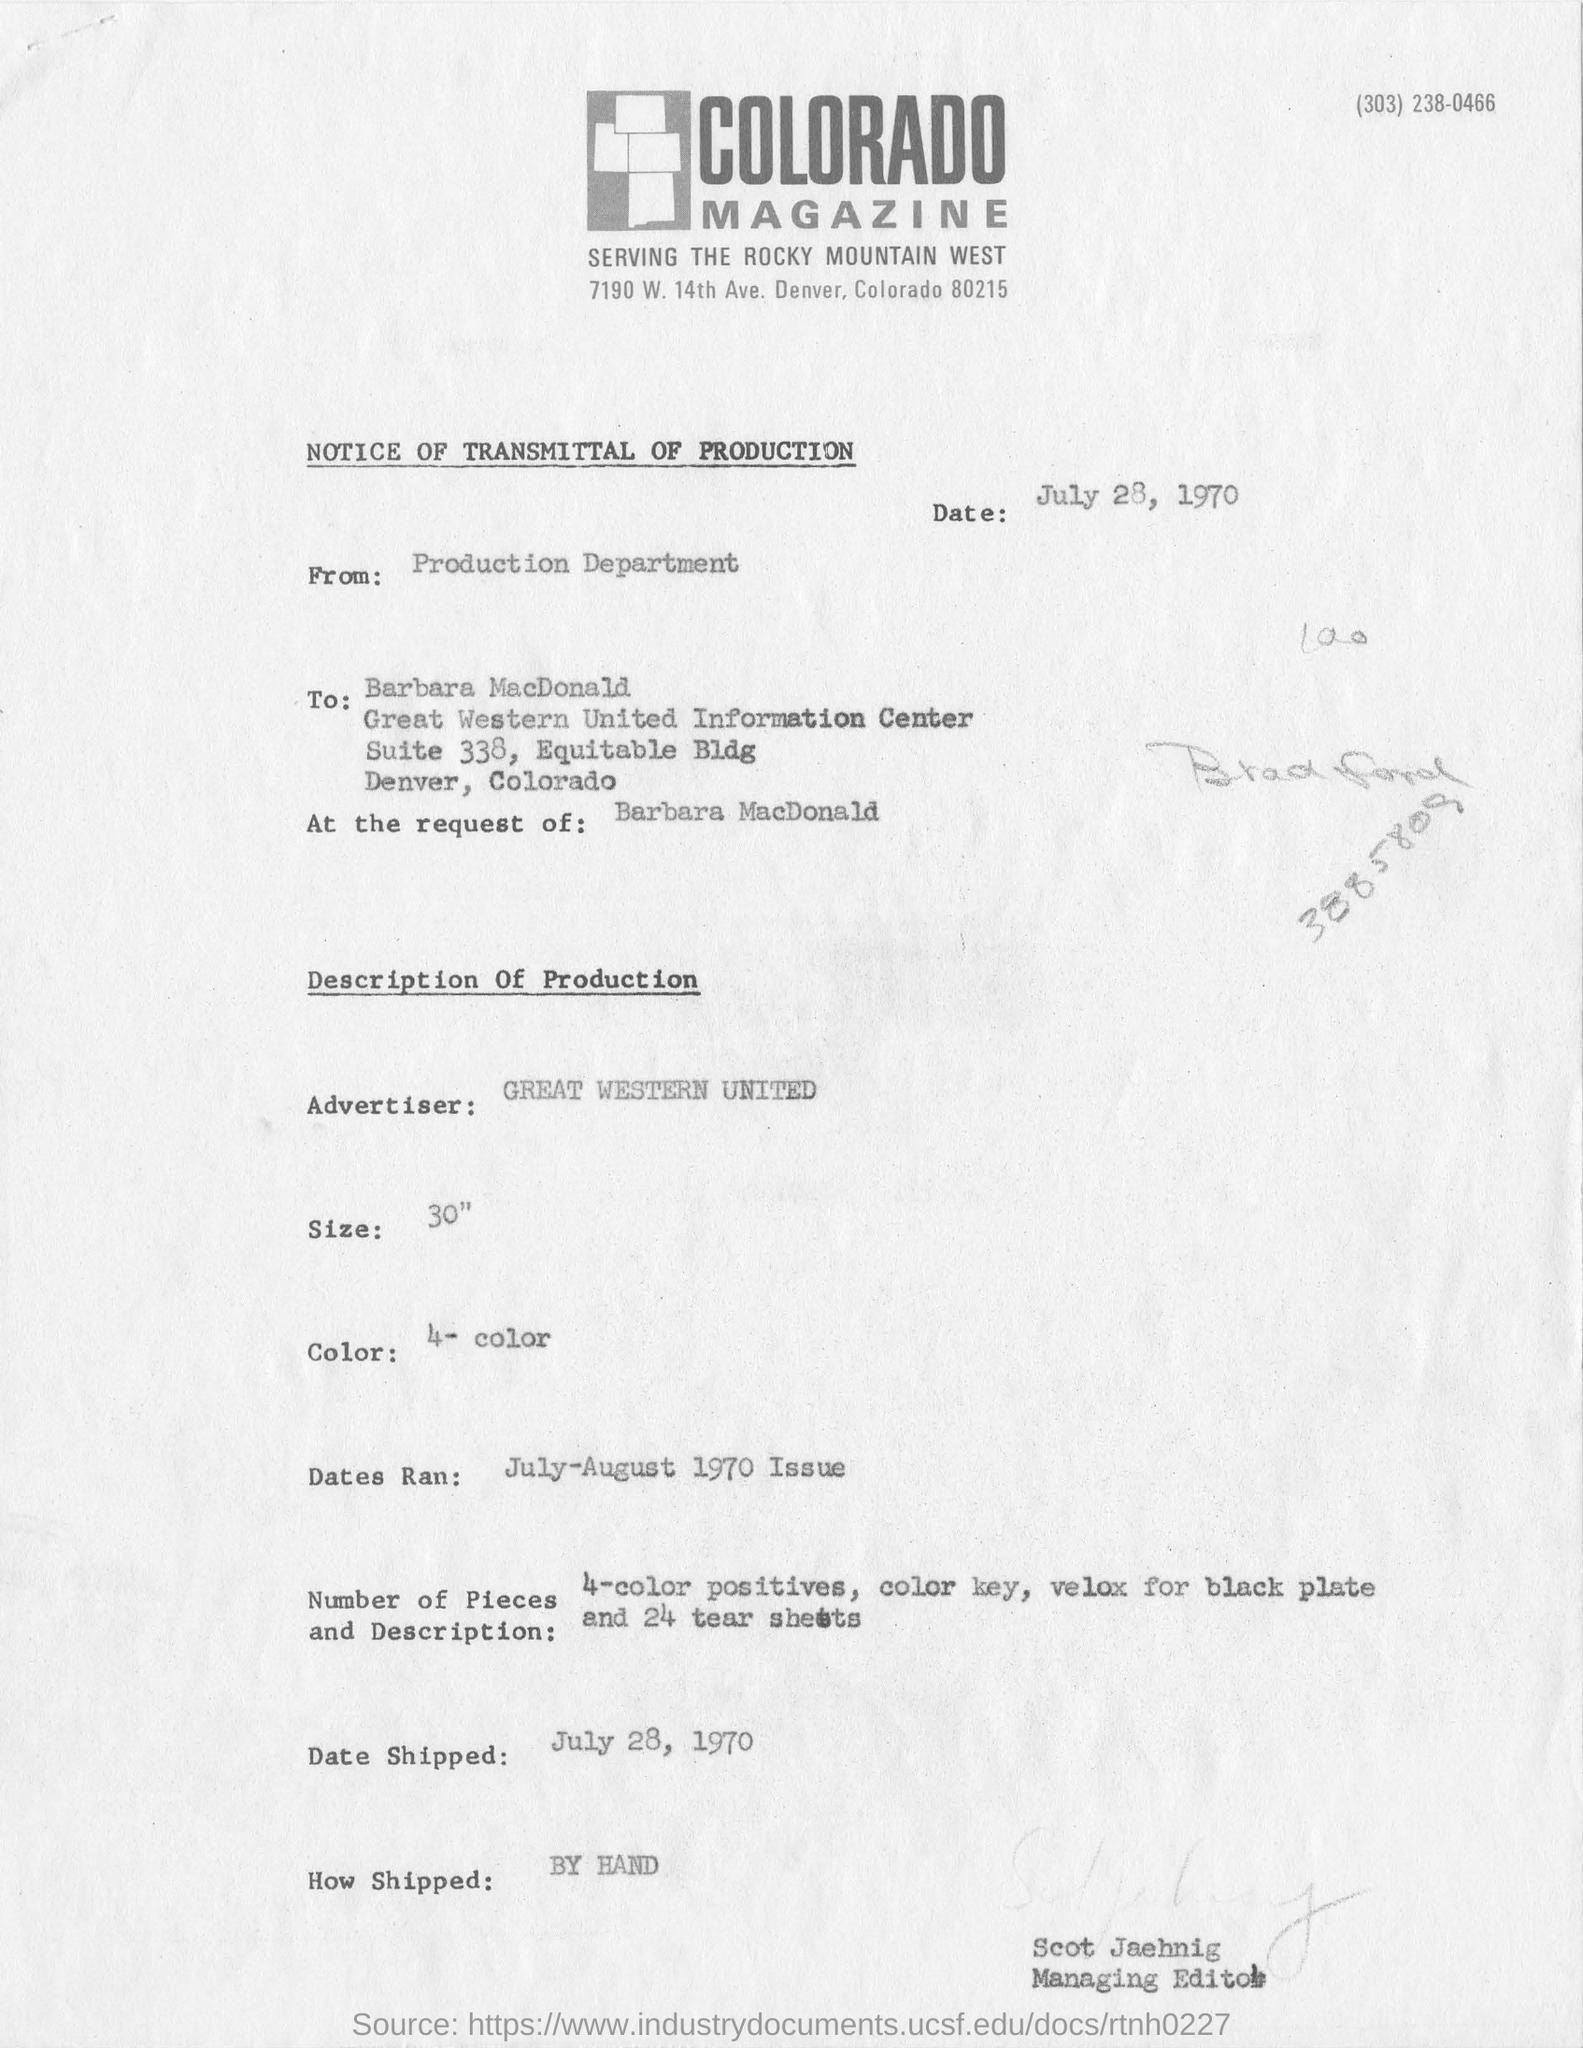Specify some key components in this picture. The advertiser company mentioned in this text is GREAT WESTERN UNITED. The recipient of the notice is Barbara MacDonald. The information written in the top right corner of the document is "303) 238-0466... The date mentioned at the beginning of this document is July 28, 1970. The shipping date is July 28, 1970. 